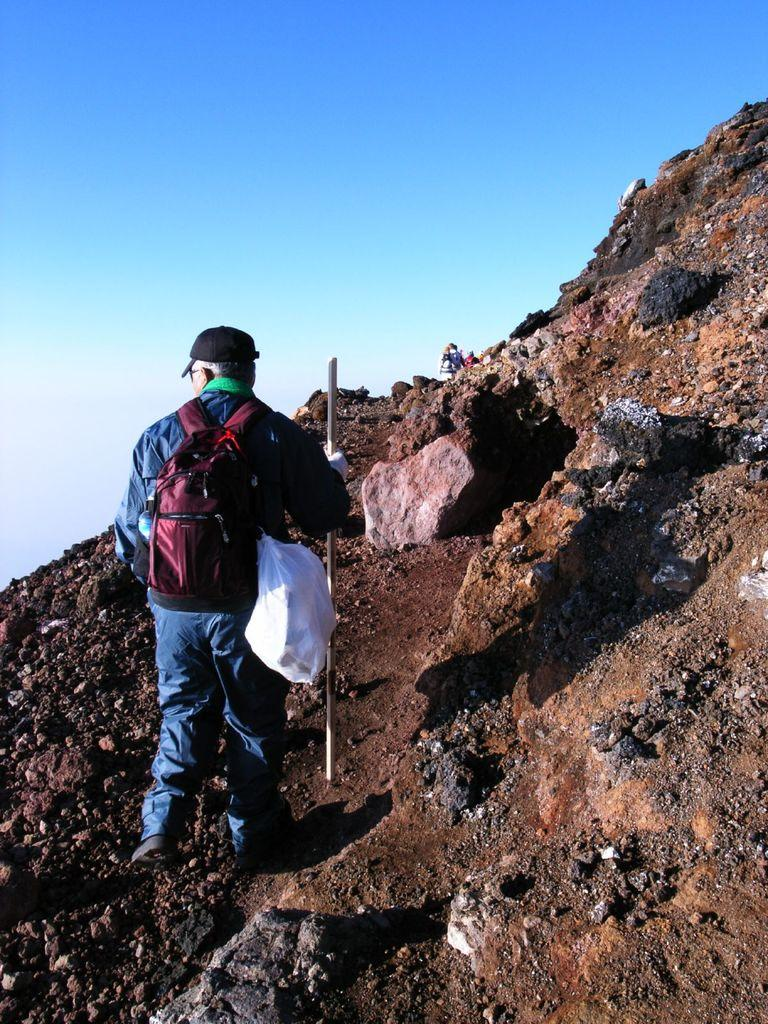What is the main subject of the image? There is a man in the image. What is the man doing in the image? The man is climbing a mountain. What is the man using to help him climb the mountain? The man is using a stick for support. What else is the man carrying while climbing the mountain? The man is carrying bags on his shoulder. What can be seen in the background of the image? There are people and the sky visible in the background of the image. What type of nerve can be seen in the image? There is no nerve present in the image; it features a man climbing a mountain with a stick and bags. Can you tell me how many books are in the library in the image? There is no library present in the image. 